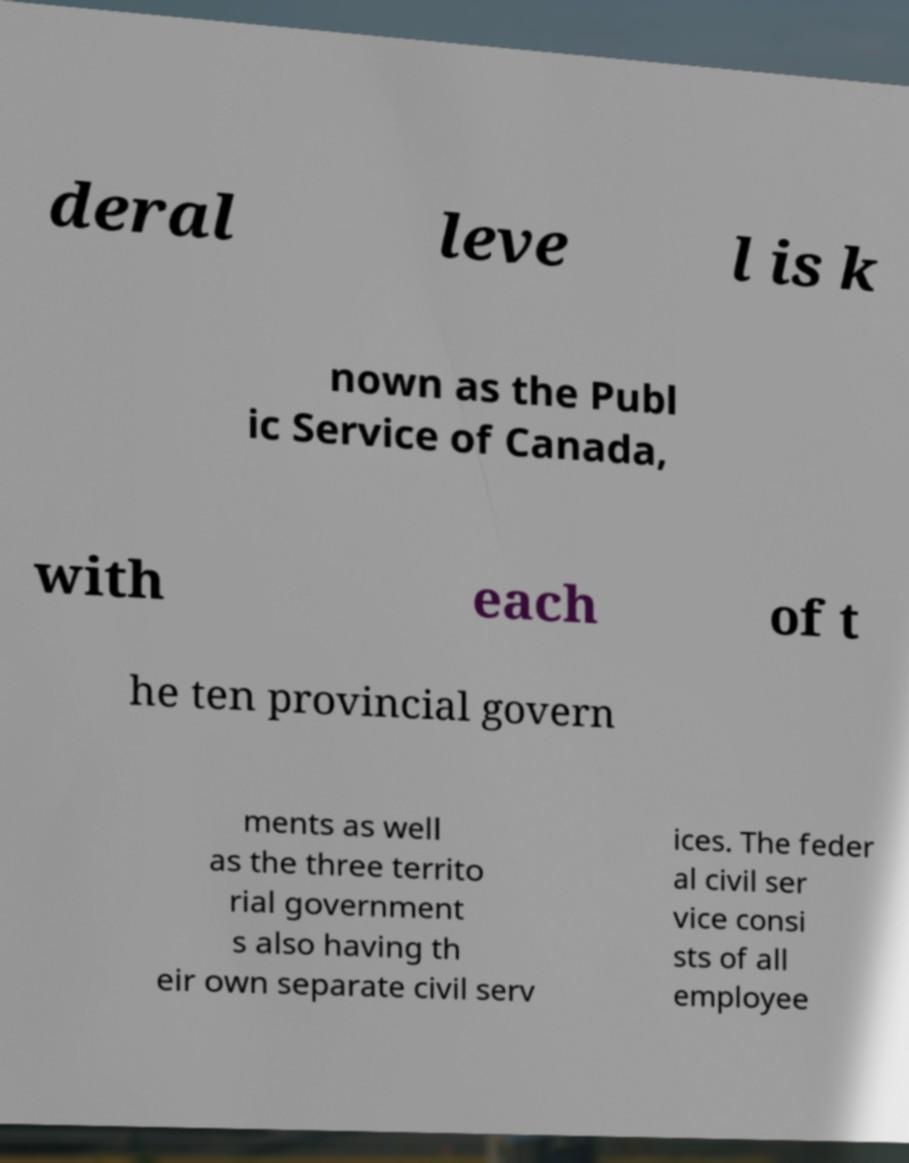Can you read and provide the text displayed in the image?This photo seems to have some interesting text. Can you extract and type it out for me? deral leve l is k nown as the Publ ic Service of Canada, with each of t he ten provincial govern ments as well as the three territo rial government s also having th eir own separate civil serv ices. The feder al civil ser vice consi sts of all employee 